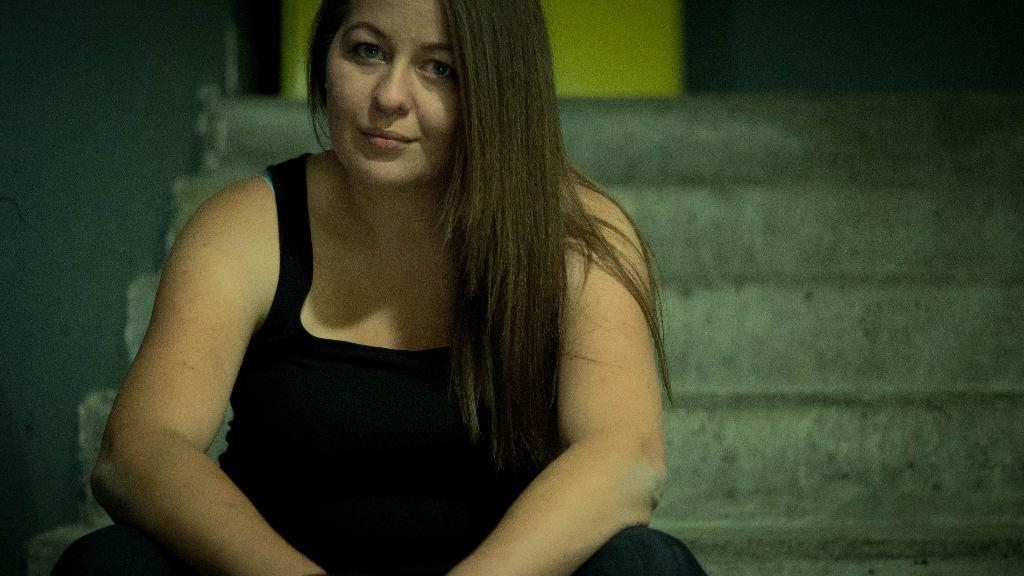Who is the main subject in the image? There is a woman in the image. What is the woman wearing? The woman is wearing a black dress. What is the woman doing in the image? The woman is posing for a photograph. Where is the woman sitting in the image? The woman is sitting on the stairs. What type of basin can be seen in the background of the image? There is no basin present in the image. How many people are in the group posing for the photograph in the image? The image only shows a single woman posing for the photograph, so there is no group present. 